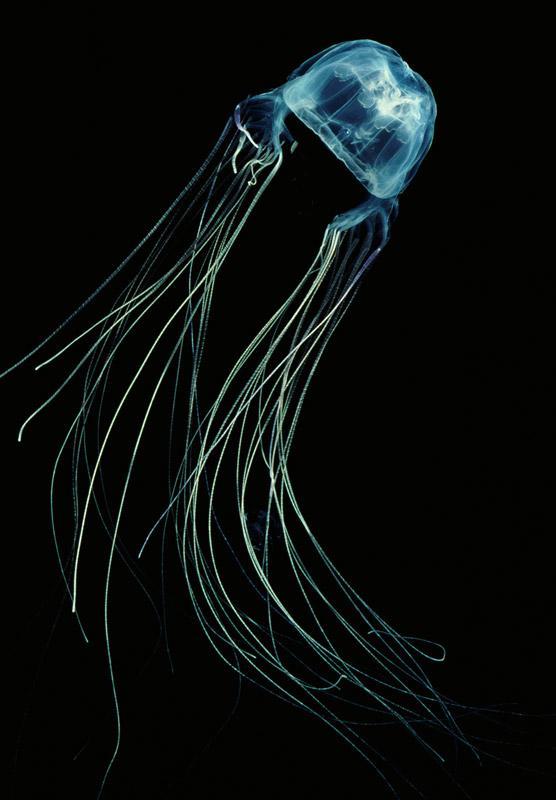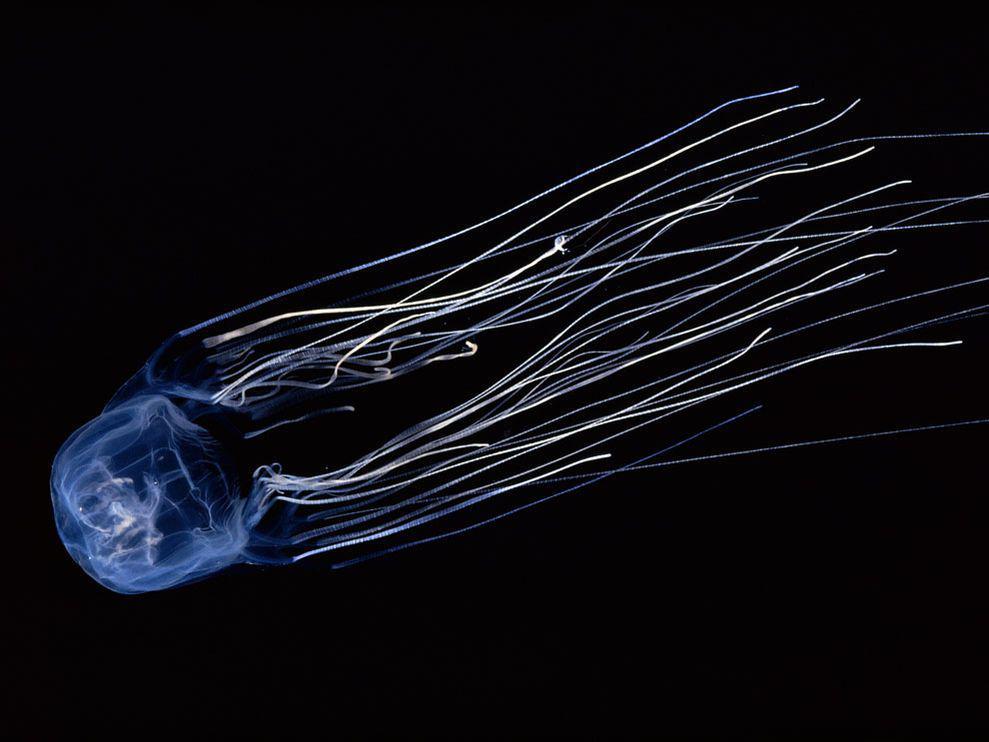The first image is the image on the left, the second image is the image on the right. Analyze the images presented: Is the assertion "Each image shows a jellyfish with a dome-shaped 'body' with only wisps of white visible inside it, and long, stringlike tentacles flowing from it." valid? Answer yes or no. Yes. The first image is the image on the left, the second image is the image on the right. Evaluate the accuracy of this statement regarding the images: "The inside of the jellyfish's body is a different color.". Is it true? Answer yes or no. No. 